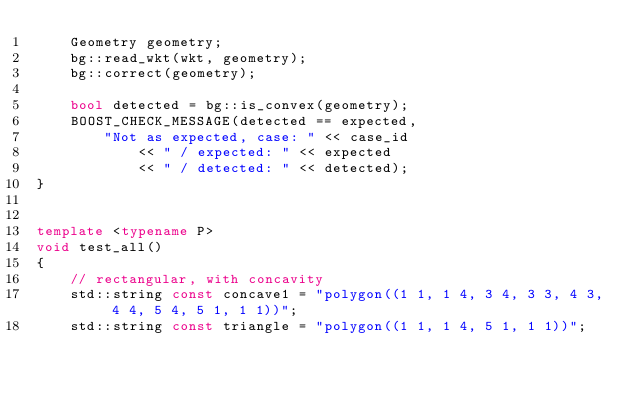<code> <loc_0><loc_0><loc_500><loc_500><_C++_>    Geometry geometry;
    bg::read_wkt(wkt, geometry);
    bg::correct(geometry);

    bool detected = bg::is_convex(geometry);
    BOOST_CHECK_MESSAGE(detected == expected,
        "Not as expected, case: " << case_id
            << " / expected: " << expected
            << " / detected: " << detected);
}


template <typename P>
void test_all()
{
    // rectangular, with concavity
    std::string const concave1 = "polygon((1 1, 1 4, 3 4, 3 3, 4 3, 4 4, 5 4, 5 1, 1 1))";
    std::string const triangle = "polygon((1 1, 1 4, 5 1, 1 1))";</code> 